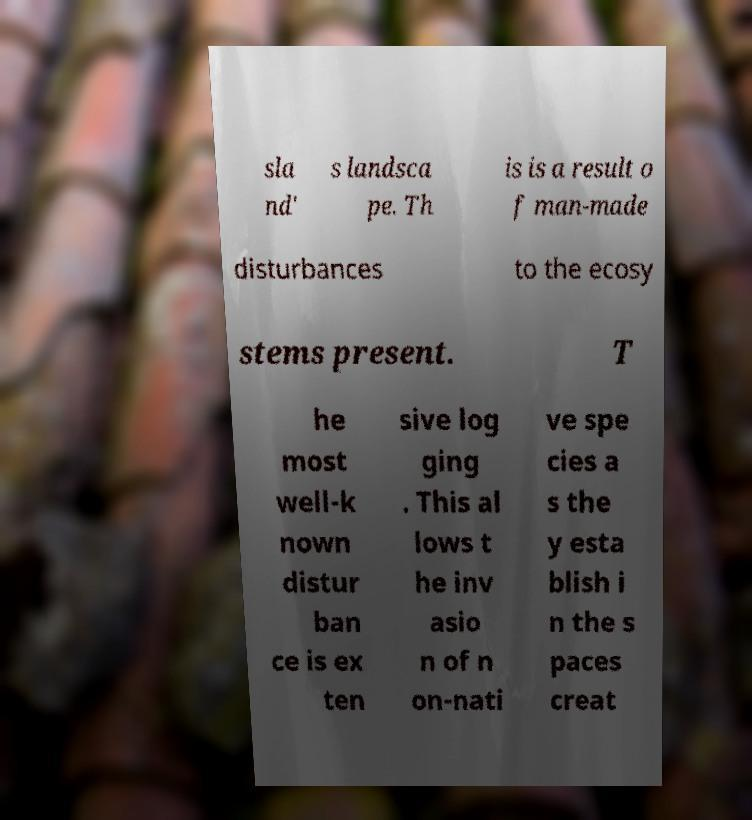What messages or text are displayed in this image? I need them in a readable, typed format. sla nd' s landsca pe. Th is is a result o f man-made disturbances to the ecosy stems present. T he most well-k nown distur ban ce is ex ten sive log ging . This al lows t he inv asio n of n on-nati ve spe cies a s the y esta blish i n the s paces creat 